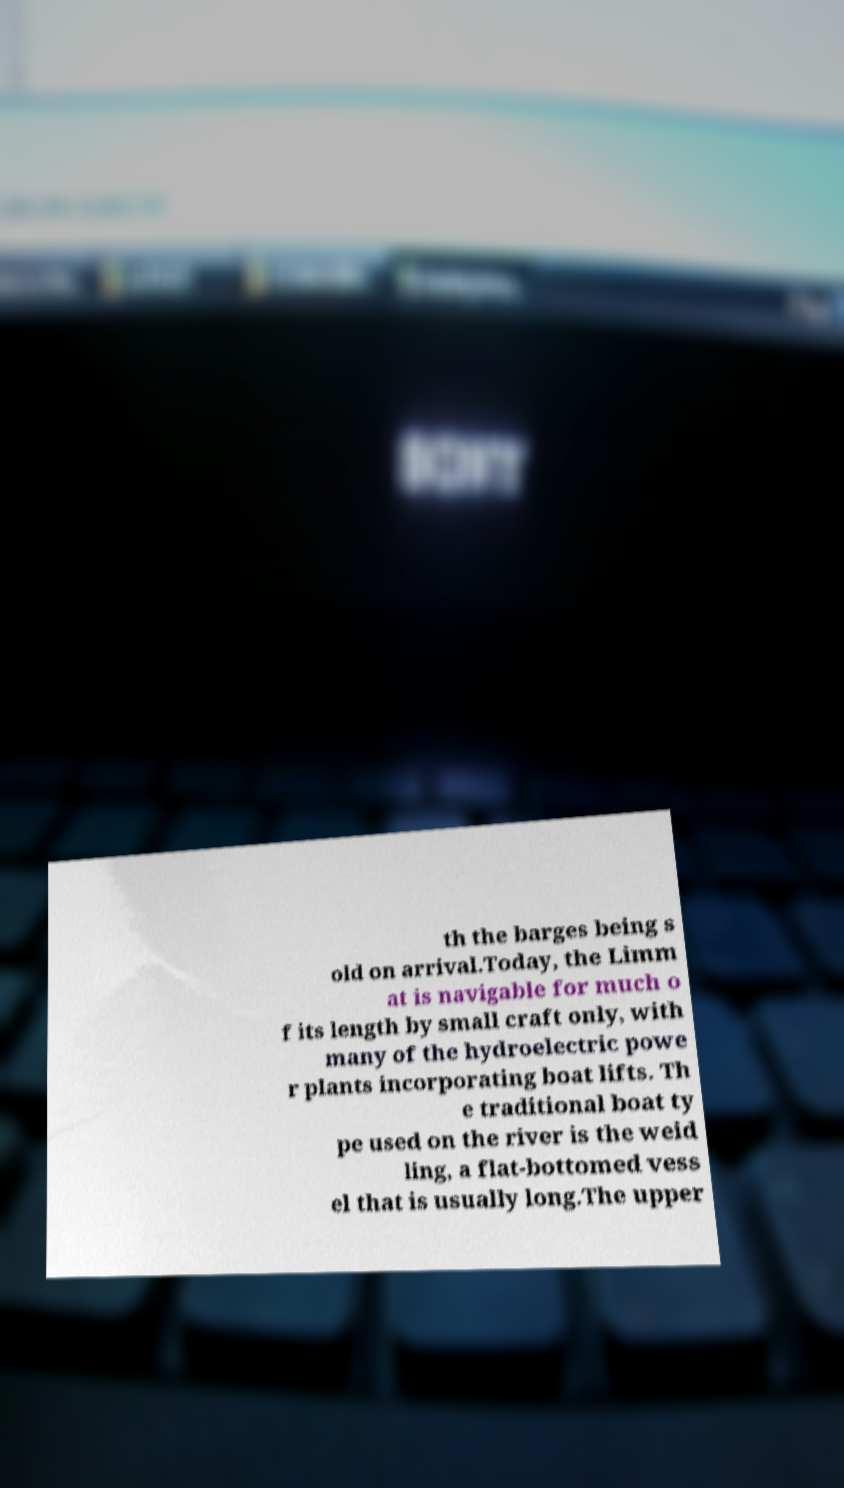For documentation purposes, I need the text within this image transcribed. Could you provide that? th the barges being s old on arrival.Today, the Limm at is navigable for much o f its length by small craft only, with many of the hydroelectric powe r plants incorporating boat lifts. Th e traditional boat ty pe used on the river is the weid ling, a flat-bottomed vess el that is usually long.The upper 